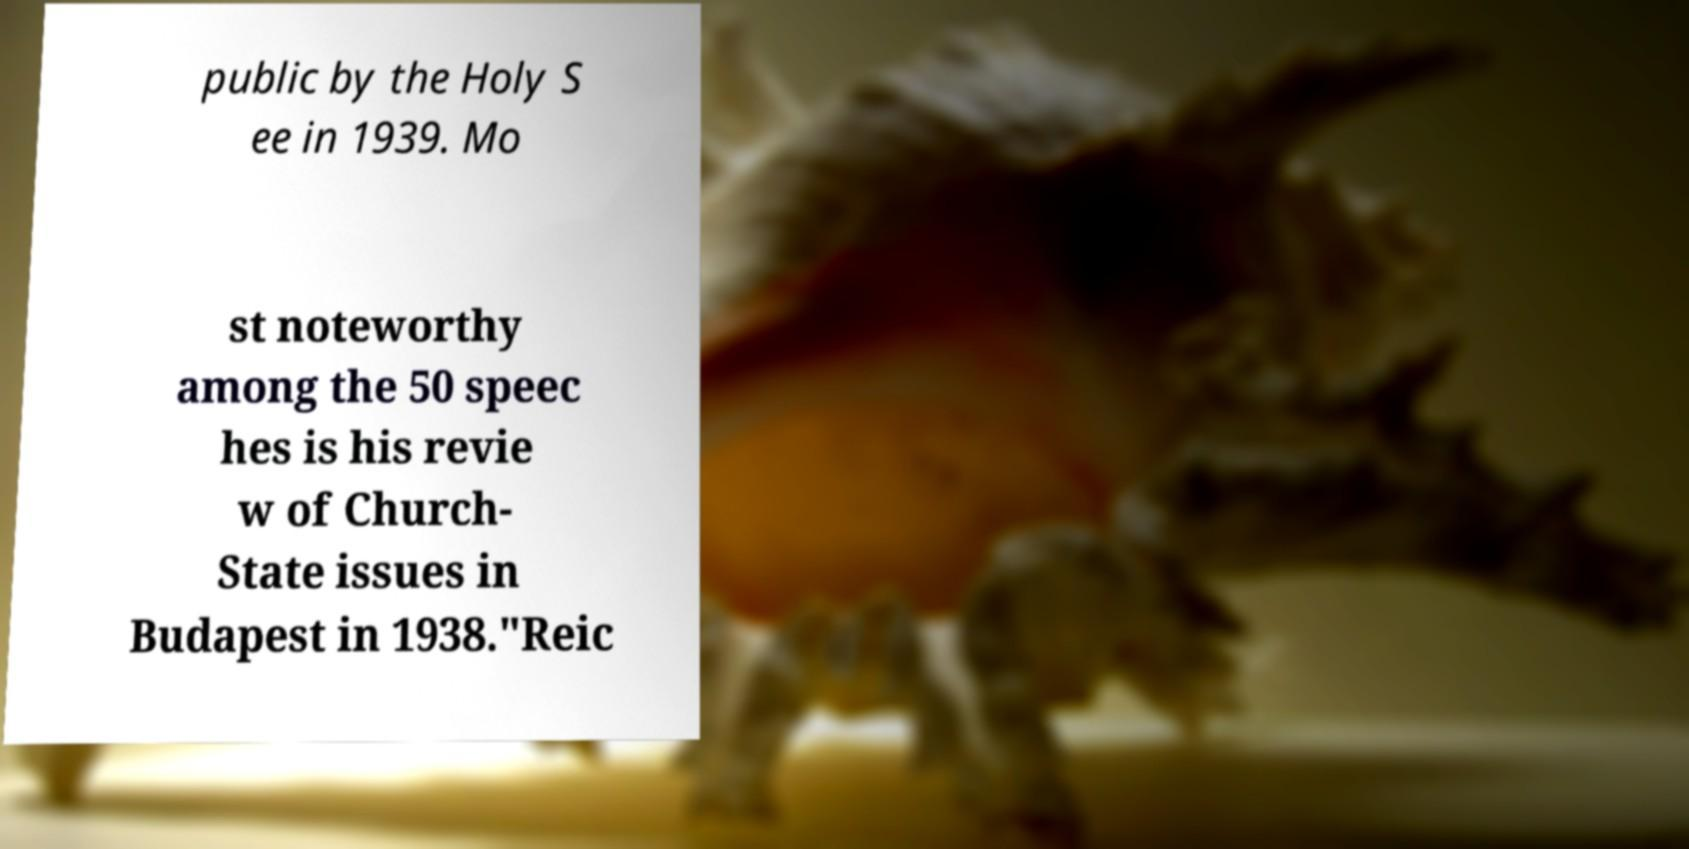Can you accurately transcribe the text from the provided image for me? public by the Holy S ee in 1939. Mo st noteworthy among the 50 speec hes is his revie w of Church- State issues in Budapest in 1938."Reic 